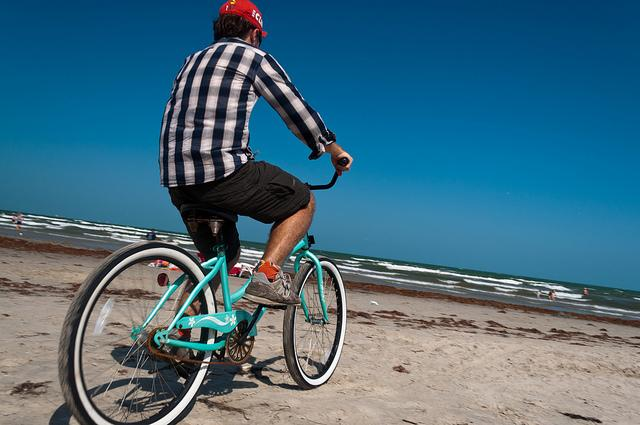What will happen to this mans feet if he doesn't stop? Please explain your reasoning. get wet. He is headed toward the water 